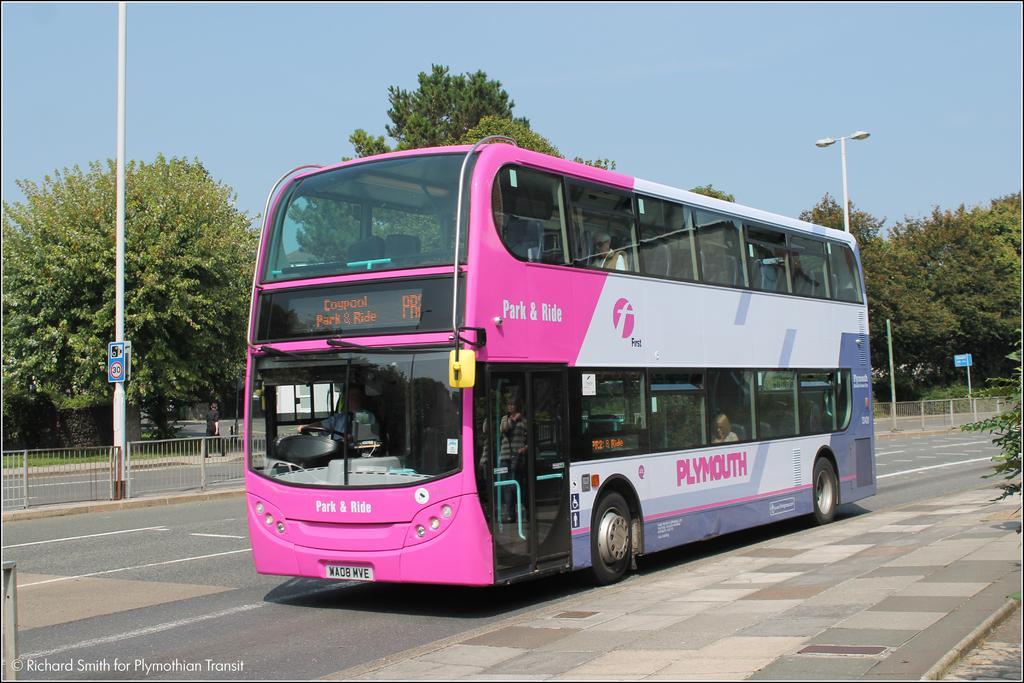Can you describe this image briefly? In the picture we can see a pink color double Decker bus on the road, we can see the fence, light poles, board, trees and the sky in the background. Here we can see the watermark on the bottom left side of the image. 